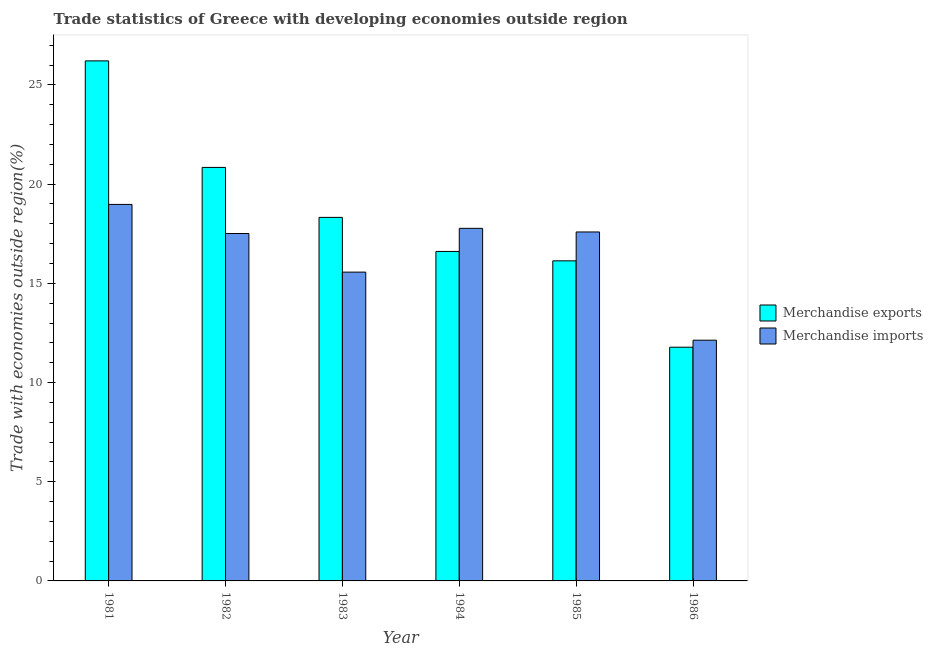How many groups of bars are there?
Make the answer very short. 6. Are the number of bars per tick equal to the number of legend labels?
Your answer should be compact. Yes. How many bars are there on the 2nd tick from the left?
Your answer should be compact. 2. What is the label of the 6th group of bars from the left?
Your response must be concise. 1986. What is the merchandise imports in 1981?
Keep it short and to the point. 18.98. Across all years, what is the maximum merchandise imports?
Offer a very short reply. 18.98. Across all years, what is the minimum merchandise imports?
Provide a succinct answer. 12.13. What is the total merchandise imports in the graph?
Offer a very short reply. 99.55. What is the difference between the merchandise imports in 1981 and that in 1985?
Give a very brief answer. 1.39. What is the difference between the merchandise imports in 1986 and the merchandise exports in 1984?
Provide a short and direct response. -5.64. What is the average merchandise exports per year?
Offer a very short reply. 18.32. In how many years, is the merchandise exports greater than 8 %?
Ensure brevity in your answer.  6. What is the ratio of the merchandise imports in 1984 to that in 1985?
Your answer should be compact. 1.01. Is the merchandise exports in 1982 less than that in 1983?
Your answer should be compact. No. What is the difference between the highest and the second highest merchandise imports?
Provide a succinct answer. 1.21. What is the difference between the highest and the lowest merchandise exports?
Keep it short and to the point. 14.43. Is the sum of the merchandise imports in 1981 and 1986 greater than the maximum merchandise exports across all years?
Keep it short and to the point. Yes. What does the 1st bar from the left in 1983 represents?
Your answer should be very brief. Merchandise exports. How many bars are there?
Your answer should be very brief. 12. Are all the bars in the graph horizontal?
Keep it short and to the point. No. Does the graph contain any zero values?
Provide a succinct answer. No. Does the graph contain grids?
Your answer should be compact. No. Where does the legend appear in the graph?
Keep it short and to the point. Center right. How many legend labels are there?
Your response must be concise. 2. What is the title of the graph?
Offer a very short reply. Trade statistics of Greece with developing economies outside region. What is the label or title of the X-axis?
Your answer should be compact. Year. What is the label or title of the Y-axis?
Keep it short and to the point. Trade with economies outside region(%). What is the Trade with economies outside region(%) in Merchandise exports in 1981?
Offer a very short reply. 26.21. What is the Trade with economies outside region(%) in Merchandise imports in 1981?
Your answer should be very brief. 18.98. What is the Trade with economies outside region(%) of Merchandise exports in 1982?
Give a very brief answer. 20.84. What is the Trade with economies outside region(%) in Merchandise imports in 1982?
Make the answer very short. 17.51. What is the Trade with economies outside region(%) of Merchandise exports in 1983?
Give a very brief answer. 18.32. What is the Trade with economies outside region(%) in Merchandise imports in 1983?
Your response must be concise. 15.57. What is the Trade with economies outside region(%) in Merchandise exports in 1984?
Keep it short and to the point. 16.61. What is the Trade with economies outside region(%) of Merchandise imports in 1984?
Make the answer very short. 17.77. What is the Trade with economies outside region(%) of Merchandise exports in 1985?
Ensure brevity in your answer.  16.13. What is the Trade with economies outside region(%) of Merchandise imports in 1985?
Ensure brevity in your answer.  17.59. What is the Trade with economies outside region(%) of Merchandise exports in 1986?
Your answer should be very brief. 11.78. What is the Trade with economies outside region(%) in Merchandise imports in 1986?
Give a very brief answer. 12.13. Across all years, what is the maximum Trade with economies outside region(%) of Merchandise exports?
Your response must be concise. 26.21. Across all years, what is the maximum Trade with economies outside region(%) in Merchandise imports?
Offer a terse response. 18.98. Across all years, what is the minimum Trade with economies outside region(%) in Merchandise exports?
Ensure brevity in your answer.  11.78. Across all years, what is the minimum Trade with economies outside region(%) in Merchandise imports?
Provide a short and direct response. 12.13. What is the total Trade with economies outside region(%) of Merchandise exports in the graph?
Provide a short and direct response. 109.91. What is the total Trade with economies outside region(%) in Merchandise imports in the graph?
Ensure brevity in your answer.  99.55. What is the difference between the Trade with economies outside region(%) in Merchandise exports in 1981 and that in 1982?
Give a very brief answer. 5.37. What is the difference between the Trade with economies outside region(%) in Merchandise imports in 1981 and that in 1982?
Keep it short and to the point. 1.47. What is the difference between the Trade with economies outside region(%) of Merchandise exports in 1981 and that in 1983?
Provide a succinct answer. 7.89. What is the difference between the Trade with economies outside region(%) of Merchandise imports in 1981 and that in 1983?
Your response must be concise. 3.41. What is the difference between the Trade with economies outside region(%) of Merchandise exports in 1981 and that in 1984?
Make the answer very short. 9.61. What is the difference between the Trade with economies outside region(%) of Merchandise imports in 1981 and that in 1984?
Your response must be concise. 1.21. What is the difference between the Trade with economies outside region(%) of Merchandise exports in 1981 and that in 1985?
Keep it short and to the point. 10.08. What is the difference between the Trade with economies outside region(%) of Merchandise imports in 1981 and that in 1985?
Your answer should be very brief. 1.39. What is the difference between the Trade with economies outside region(%) in Merchandise exports in 1981 and that in 1986?
Your response must be concise. 14.43. What is the difference between the Trade with economies outside region(%) in Merchandise imports in 1981 and that in 1986?
Make the answer very short. 6.84. What is the difference between the Trade with economies outside region(%) of Merchandise exports in 1982 and that in 1983?
Give a very brief answer. 2.52. What is the difference between the Trade with economies outside region(%) of Merchandise imports in 1982 and that in 1983?
Your answer should be very brief. 1.95. What is the difference between the Trade with economies outside region(%) of Merchandise exports in 1982 and that in 1984?
Provide a succinct answer. 4.24. What is the difference between the Trade with economies outside region(%) in Merchandise imports in 1982 and that in 1984?
Offer a terse response. -0.26. What is the difference between the Trade with economies outside region(%) of Merchandise exports in 1982 and that in 1985?
Provide a short and direct response. 4.71. What is the difference between the Trade with economies outside region(%) in Merchandise imports in 1982 and that in 1985?
Keep it short and to the point. -0.08. What is the difference between the Trade with economies outside region(%) of Merchandise exports in 1982 and that in 1986?
Your response must be concise. 9.06. What is the difference between the Trade with economies outside region(%) of Merchandise imports in 1982 and that in 1986?
Your answer should be compact. 5.38. What is the difference between the Trade with economies outside region(%) in Merchandise exports in 1983 and that in 1984?
Offer a terse response. 1.72. What is the difference between the Trade with economies outside region(%) in Merchandise imports in 1983 and that in 1984?
Keep it short and to the point. -2.21. What is the difference between the Trade with economies outside region(%) in Merchandise exports in 1983 and that in 1985?
Keep it short and to the point. 2.19. What is the difference between the Trade with economies outside region(%) in Merchandise imports in 1983 and that in 1985?
Your answer should be very brief. -2.02. What is the difference between the Trade with economies outside region(%) of Merchandise exports in 1983 and that in 1986?
Your answer should be very brief. 6.54. What is the difference between the Trade with economies outside region(%) of Merchandise imports in 1983 and that in 1986?
Give a very brief answer. 3.43. What is the difference between the Trade with economies outside region(%) in Merchandise exports in 1984 and that in 1985?
Ensure brevity in your answer.  0.47. What is the difference between the Trade with economies outside region(%) in Merchandise imports in 1984 and that in 1985?
Make the answer very short. 0.18. What is the difference between the Trade with economies outside region(%) of Merchandise exports in 1984 and that in 1986?
Provide a succinct answer. 4.83. What is the difference between the Trade with economies outside region(%) of Merchandise imports in 1984 and that in 1986?
Give a very brief answer. 5.64. What is the difference between the Trade with economies outside region(%) in Merchandise exports in 1985 and that in 1986?
Provide a succinct answer. 4.35. What is the difference between the Trade with economies outside region(%) of Merchandise imports in 1985 and that in 1986?
Provide a short and direct response. 5.46. What is the difference between the Trade with economies outside region(%) of Merchandise exports in 1981 and the Trade with economies outside region(%) of Merchandise imports in 1982?
Give a very brief answer. 8.7. What is the difference between the Trade with economies outside region(%) of Merchandise exports in 1981 and the Trade with economies outside region(%) of Merchandise imports in 1983?
Your answer should be very brief. 10.65. What is the difference between the Trade with economies outside region(%) of Merchandise exports in 1981 and the Trade with economies outside region(%) of Merchandise imports in 1984?
Your answer should be compact. 8.44. What is the difference between the Trade with economies outside region(%) in Merchandise exports in 1981 and the Trade with economies outside region(%) in Merchandise imports in 1985?
Make the answer very short. 8.62. What is the difference between the Trade with economies outside region(%) of Merchandise exports in 1981 and the Trade with economies outside region(%) of Merchandise imports in 1986?
Keep it short and to the point. 14.08. What is the difference between the Trade with economies outside region(%) in Merchandise exports in 1982 and the Trade with economies outside region(%) in Merchandise imports in 1983?
Offer a very short reply. 5.28. What is the difference between the Trade with economies outside region(%) in Merchandise exports in 1982 and the Trade with economies outside region(%) in Merchandise imports in 1984?
Give a very brief answer. 3.07. What is the difference between the Trade with economies outside region(%) in Merchandise exports in 1982 and the Trade with economies outside region(%) in Merchandise imports in 1985?
Provide a succinct answer. 3.25. What is the difference between the Trade with economies outside region(%) of Merchandise exports in 1982 and the Trade with economies outside region(%) of Merchandise imports in 1986?
Your response must be concise. 8.71. What is the difference between the Trade with economies outside region(%) in Merchandise exports in 1983 and the Trade with economies outside region(%) in Merchandise imports in 1984?
Keep it short and to the point. 0.55. What is the difference between the Trade with economies outside region(%) in Merchandise exports in 1983 and the Trade with economies outside region(%) in Merchandise imports in 1985?
Make the answer very short. 0.73. What is the difference between the Trade with economies outside region(%) in Merchandise exports in 1983 and the Trade with economies outside region(%) in Merchandise imports in 1986?
Ensure brevity in your answer.  6.19. What is the difference between the Trade with economies outside region(%) of Merchandise exports in 1984 and the Trade with economies outside region(%) of Merchandise imports in 1985?
Ensure brevity in your answer.  -0.98. What is the difference between the Trade with economies outside region(%) in Merchandise exports in 1984 and the Trade with economies outside region(%) in Merchandise imports in 1986?
Offer a terse response. 4.47. What is the difference between the Trade with economies outside region(%) of Merchandise exports in 1985 and the Trade with economies outside region(%) of Merchandise imports in 1986?
Provide a short and direct response. 4. What is the average Trade with economies outside region(%) in Merchandise exports per year?
Provide a short and direct response. 18.32. What is the average Trade with economies outside region(%) of Merchandise imports per year?
Give a very brief answer. 16.59. In the year 1981, what is the difference between the Trade with economies outside region(%) in Merchandise exports and Trade with economies outside region(%) in Merchandise imports?
Your response must be concise. 7.24. In the year 1982, what is the difference between the Trade with economies outside region(%) of Merchandise exports and Trade with economies outside region(%) of Merchandise imports?
Offer a very short reply. 3.33. In the year 1983, what is the difference between the Trade with economies outside region(%) in Merchandise exports and Trade with economies outside region(%) in Merchandise imports?
Make the answer very short. 2.76. In the year 1984, what is the difference between the Trade with economies outside region(%) in Merchandise exports and Trade with economies outside region(%) in Merchandise imports?
Give a very brief answer. -1.16. In the year 1985, what is the difference between the Trade with economies outside region(%) in Merchandise exports and Trade with economies outside region(%) in Merchandise imports?
Ensure brevity in your answer.  -1.46. In the year 1986, what is the difference between the Trade with economies outside region(%) of Merchandise exports and Trade with economies outside region(%) of Merchandise imports?
Offer a terse response. -0.35. What is the ratio of the Trade with economies outside region(%) of Merchandise exports in 1981 to that in 1982?
Ensure brevity in your answer.  1.26. What is the ratio of the Trade with economies outside region(%) of Merchandise imports in 1981 to that in 1982?
Offer a terse response. 1.08. What is the ratio of the Trade with economies outside region(%) of Merchandise exports in 1981 to that in 1983?
Provide a succinct answer. 1.43. What is the ratio of the Trade with economies outside region(%) in Merchandise imports in 1981 to that in 1983?
Keep it short and to the point. 1.22. What is the ratio of the Trade with economies outside region(%) in Merchandise exports in 1981 to that in 1984?
Your answer should be very brief. 1.58. What is the ratio of the Trade with economies outside region(%) of Merchandise imports in 1981 to that in 1984?
Make the answer very short. 1.07. What is the ratio of the Trade with economies outside region(%) in Merchandise exports in 1981 to that in 1985?
Give a very brief answer. 1.62. What is the ratio of the Trade with economies outside region(%) of Merchandise imports in 1981 to that in 1985?
Provide a succinct answer. 1.08. What is the ratio of the Trade with economies outside region(%) of Merchandise exports in 1981 to that in 1986?
Ensure brevity in your answer.  2.23. What is the ratio of the Trade with economies outside region(%) in Merchandise imports in 1981 to that in 1986?
Provide a short and direct response. 1.56. What is the ratio of the Trade with economies outside region(%) in Merchandise exports in 1982 to that in 1983?
Give a very brief answer. 1.14. What is the ratio of the Trade with economies outside region(%) of Merchandise imports in 1982 to that in 1983?
Offer a terse response. 1.13. What is the ratio of the Trade with economies outside region(%) of Merchandise exports in 1982 to that in 1984?
Your response must be concise. 1.26. What is the ratio of the Trade with economies outside region(%) in Merchandise imports in 1982 to that in 1984?
Keep it short and to the point. 0.99. What is the ratio of the Trade with economies outside region(%) of Merchandise exports in 1982 to that in 1985?
Your response must be concise. 1.29. What is the ratio of the Trade with economies outside region(%) in Merchandise imports in 1982 to that in 1985?
Your answer should be compact. 1. What is the ratio of the Trade with economies outside region(%) in Merchandise exports in 1982 to that in 1986?
Offer a very short reply. 1.77. What is the ratio of the Trade with economies outside region(%) of Merchandise imports in 1982 to that in 1986?
Keep it short and to the point. 1.44. What is the ratio of the Trade with economies outside region(%) of Merchandise exports in 1983 to that in 1984?
Keep it short and to the point. 1.1. What is the ratio of the Trade with economies outside region(%) of Merchandise imports in 1983 to that in 1984?
Your answer should be compact. 0.88. What is the ratio of the Trade with economies outside region(%) in Merchandise exports in 1983 to that in 1985?
Provide a short and direct response. 1.14. What is the ratio of the Trade with economies outside region(%) of Merchandise imports in 1983 to that in 1985?
Your answer should be compact. 0.88. What is the ratio of the Trade with economies outside region(%) in Merchandise exports in 1983 to that in 1986?
Give a very brief answer. 1.56. What is the ratio of the Trade with economies outside region(%) in Merchandise imports in 1983 to that in 1986?
Give a very brief answer. 1.28. What is the ratio of the Trade with economies outside region(%) of Merchandise exports in 1984 to that in 1985?
Keep it short and to the point. 1.03. What is the ratio of the Trade with economies outside region(%) of Merchandise imports in 1984 to that in 1985?
Provide a succinct answer. 1.01. What is the ratio of the Trade with economies outside region(%) in Merchandise exports in 1984 to that in 1986?
Your answer should be very brief. 1.41. What is the ratio of the Trade with economies outside region(%) in Merchandise imports in 1984 to that in 1986?
Your response must be concise. 1.46. What is the ratio of the Trade with economies outside region(%) in Merchandise exports in 1985 to that in 1986?
Offer a terse response. 1.37. What is the ratio of the Trade with economies outside region(%) in Merchandise imports in 1985 to that in 1986?
Give a very brief answer. 1.45. What is the difference between the highest and the second highest Trade with economies outside region(%) of Merchandise exports?
Ensure brevity in your answer.  5.37. What is the difference between the highest and the second highest Trade with economies outside region(%) of Merchandise imports?
Offer a very short reply. 1.21. What is the difference between the highest and the lowest Trade with economies outside region(%) in Merchandise exports?
Offer a very short reply. 14.43. What is the difference between the highest and the lowest Trade with economies outside region(%) in Merchandise imports?
Offer a very short reply. 6.84. 